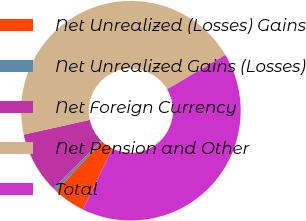Convert chart to OTSL. <chart><loc_0><loc_0><loc_500><loc_500><pie_chart><fcel>Net Unrealized (Losses) Gains<fcel>Net Unrealized Gains (Losses)<fcel>Net Foreign Currency<fcel>Net Pension and Other<fcel>Total<nl><fcel>4.77%<fcel>0.48%<fcel>9.06%<fcel>44.99%<fcel>40.7%<nl></chart> 